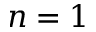<formula> <loc_0><loc_0><loc_500><loc_500>n = 1</formula> 